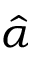Convert formula to latex. <formula><loc_0><loc_0><loc_500><loc_500>\hat { \alpha }</formula> 